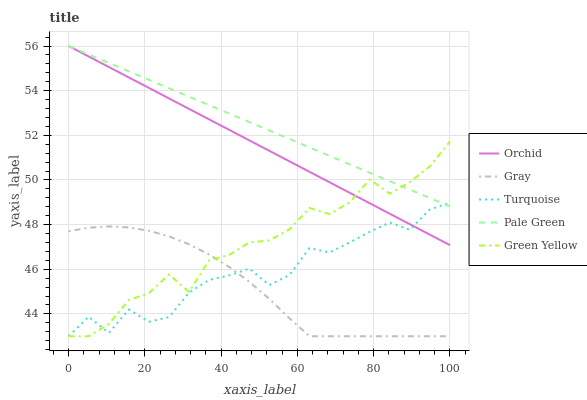Does Gray have the minimum area under the curve?
Answer yes or no. Yes. Does Pale Green have the maximum area under the curve?
Answer yes or no. Yes. Does Turquoise have the minimum area under the curve?
Answer yes or no. No. Does Turquoise have the maximum area under the curve?
Answer yes or no. No. Is Orchid the smoothest?
Answer yes or no. Yes. Is Turquoise the roughest?
Answer yes or no. Yes. Is Pale Green the smoothest?
Answer yes or no. No. Is Pale Green the roughest?
Answer yes or no. No. Does Gray have the lowest value?
Answer yes or no. Yes. Does Pale Green have the lowest value?
Answer yes or no. No. Does Orchid have the highest value?
Answer yes or no. Yes. Does Turquoise have the highest value?
Answer yes or no. No. Is Gray less than Orchid?
Answer yes or no. Yes. Is Orchid greater than Gray?
Answer yes or no. Yes. Does Turquoise intersect Pale Green?
Answer yes or no. Yes. Is Turquoise less than Pale Green?
Answer yes or no. No. Is Turquoise greater than Pale Green?
Answer yes or no. No. Does Gray intersect Orchid?
Answer yes or no. No. 